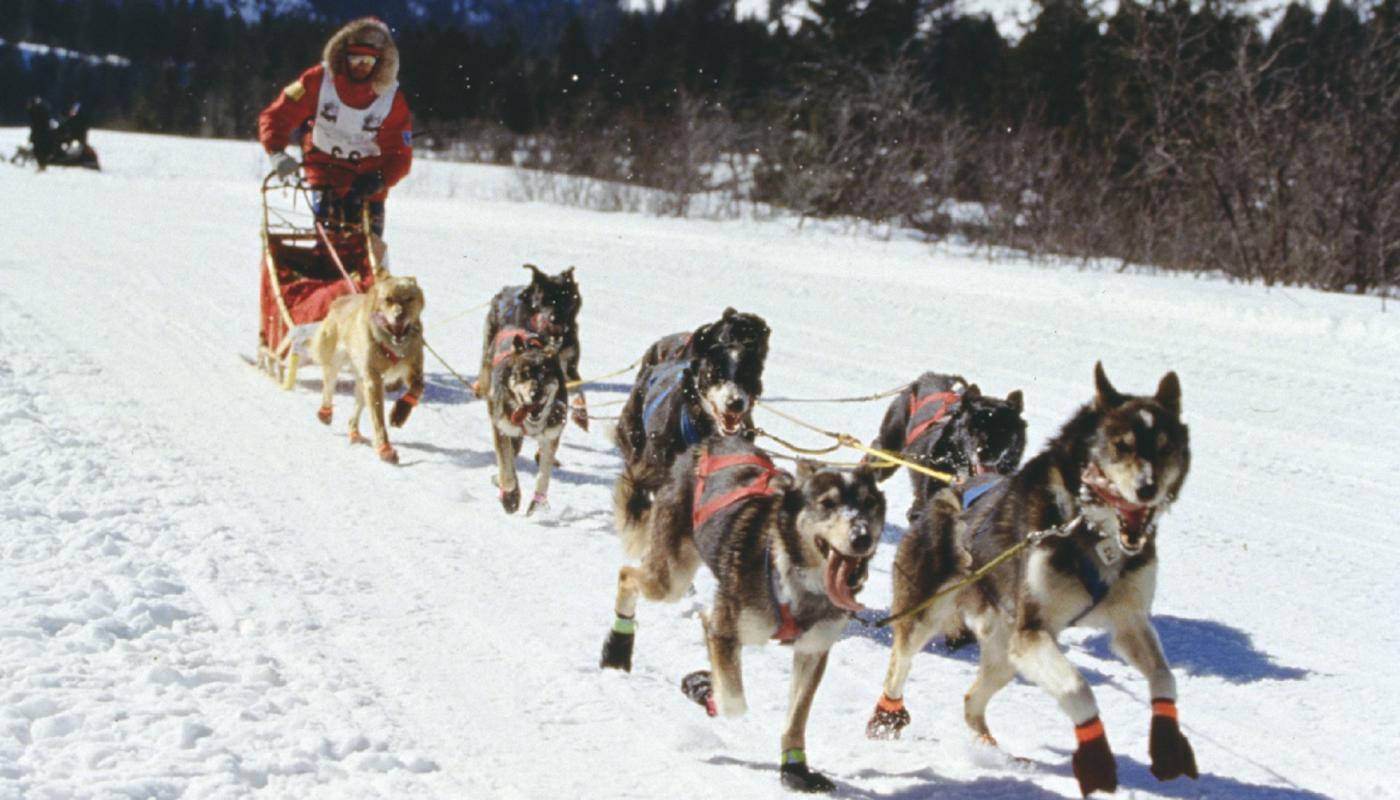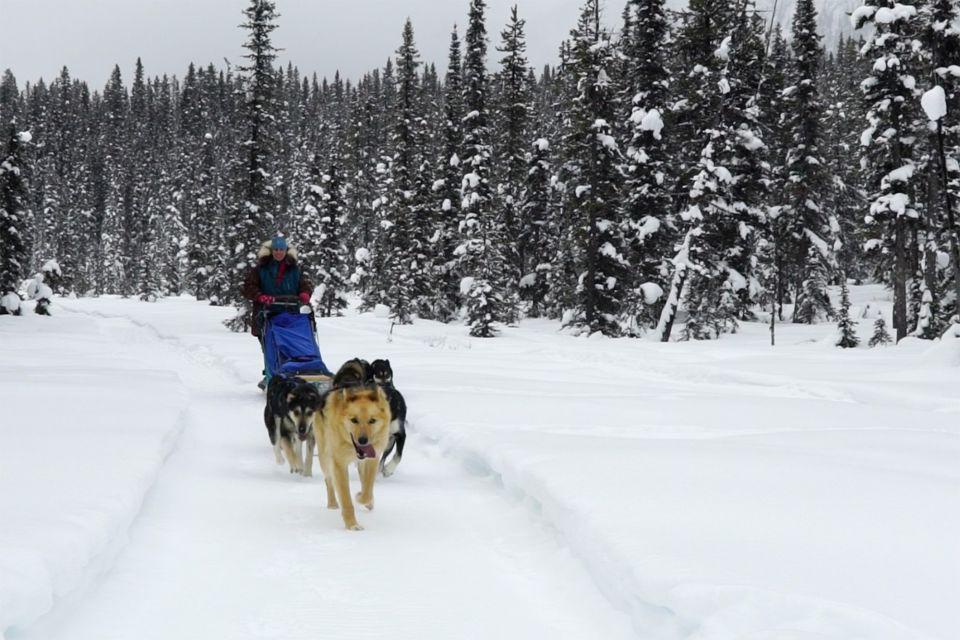The first image is the image on the left, the second image is the image on the right. Assess this claim about the two images: "No lead sled dogs wear booties, and a sled driver is not visible in at least one image.". Correct or not? Answer yes or no. No. The first image is the image on the left, the second image is the image on the right. For the images shown, is this caption "There is no human visible in one of the images." true? Answer yes or no. No. 